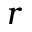Convert formula to latex. <formula><loc_0><loc_0><loc_500><loc_500>r</formula> 